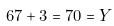<formula> <loc_0><loc_0><loc_500><loc_500>6 7 + 3 = 7 0 = Y</formula> 